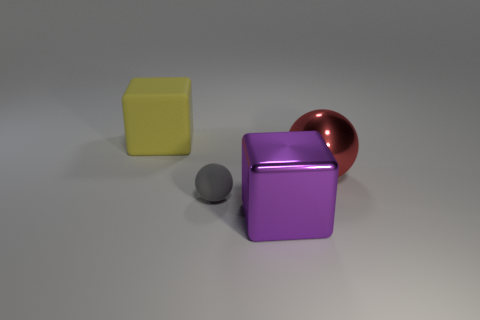Add 2 big green rubber cubes. How many objects exist? 6 Add 3 big metal objects. How many big metal objects are left? 5 Add 3 gray matte objects. How many gray matte objects exist? 4 Subtract 0 green balls. How many objects are left? 4 Subtract all large purple metal things. Subtract all small cyan cubes. How many objects are left? 3 